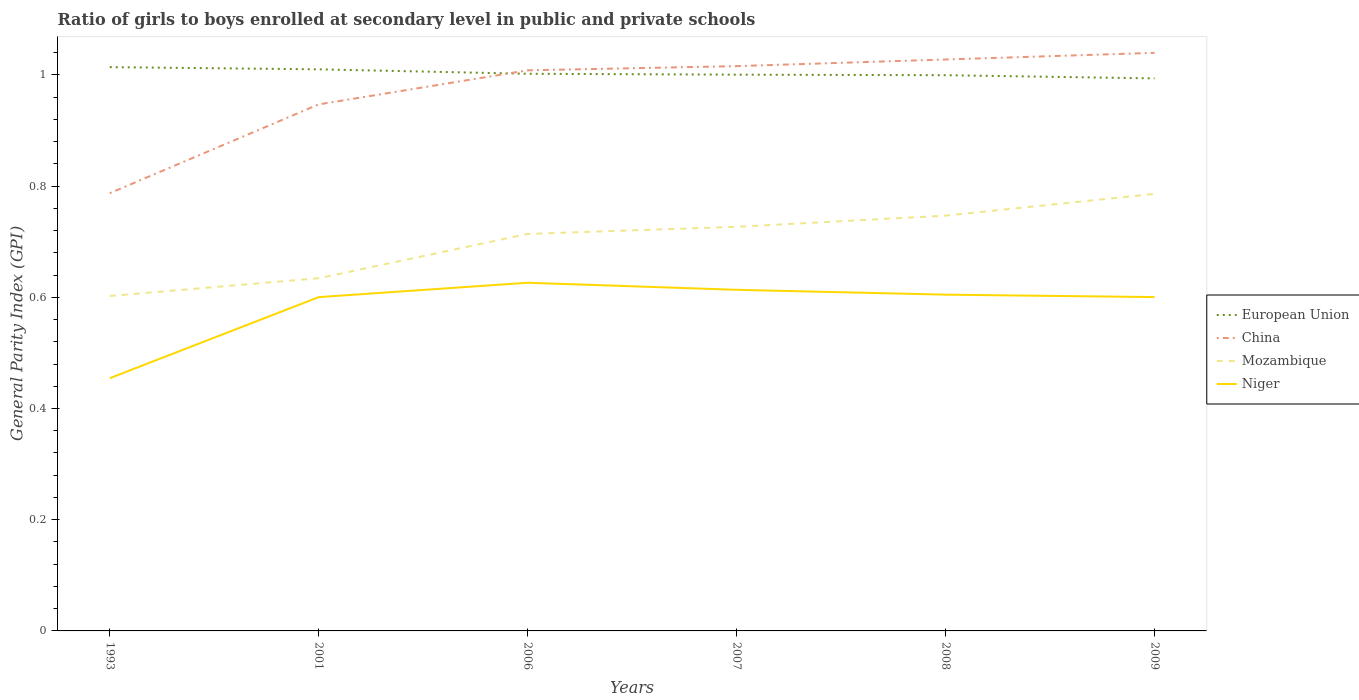Is the number of lines equal to the number of legend labels?
Your response must be concise. Yes. Across all years, what is the maximum general parity index in European Union?
Keep it short and to the point. 0.99. In which year was the general parity index in Mozambique maximum?
Ensure brevity in your answer.  1993. What is the total general parity index in China in the graph?
Provide a short and direct response. -0.16. What is the difference between the highest and the second highest general parity index in European Union?
Make the answer very short. 0.02. Is the general parity index in Niger strictly greater than the general parity index in Mozambique over the years?
Provide a succinct answer. Yes. How many lines are there?
Your answer should be compact. 4. How many years are there in the graph?
Your answer should be compact. 6. What is the difference between two consecutive major ticks on the Y-axis?
Offer a terse response. 0.2. Are the values on the major ticks of Y-axis written in scientific E-notation?
Ensure brevity in your answer.  No. Where does the legend appear in the graph?
Your response must be concise. Center right. How many legend labels are there?
Offer a terse response. 4. How are the legend labels stacked?
Your answer should be compact. Vertical. What is the title of the graph?
Your answer should be very brief. Ratio of girls to boys enrolled at secondary level in public and private schools. Does "Tajikistan" appear as one of the legend labels in the graph?
Offer a terse response. No. What is the label or title of the Y-axis?
Give a very brief answer. General Parity Index (GPI). What is the General Parity Index (GPI) in European Union in 1993?
Offer a terse response. 1.01. What is the General Parity Index (GPI) in China in 1993?
Offer a terse response. 0.79. What is the General Parity Index (GPI) in Mozambique in 1993?
Provide a short and direct response. 0.6. What is the General Parity Index (GPI) of Niger in 1993?
Your answer should be very brief. 0.45. What is the General Parity Index (GPI) of European Union in 2001?
Offer a very short reply. 1.01. What is the General Parity Index (GPI) in China in 2001?
Your response must be concise. 0.95. What is the General Parity Index (GPI) of Mozambique in 2001?
Your answer should be very brief. 0.63. What is the General Parity Index (GPI) of Niger in 2001?
Provide a succinct answer. 0.6. What is the General Parity Index (GPI) of European Union in 2006?
Offer a very short reply. 1. What is the General Parity Index (GPI) of China in 2006?
Your answer should be very brief. 1.01. What is the General Parity Index (GPI) in Mozambique in 2006?
Your response must be concise. 0.71. What is the General Parity Index (GPI) in Niger in 2006?
Provide a succinct answer. 0.63. What is the General Parity Index (GPI) of European Union in 2007?
Give a very brief answer. 1. What is the General Parity Index (GPI) of China in 2007?
Keep it short and to the point. 1.02. What is the General Parity Index (GPI) in Mozambique in 2007?
Your answer should be compact. 0.73. What is the General Parity Index (GPI) of Niger in 2007?
Ensure brevity in your answer.  0.61. What is the General Parity Index (GPI) of European Union in 2008?
Provide a succinct answer. 1. What is the General Parity Index (GPI) in China in 2008?
Give a very brief answer. 1.03. What is the General Parity Index (GPI) of Mozambique in 2008?
Your response must be concise. 0.75. What is the General Parity Index (GPI) in Niger in 2008?
Your answer should be very brief. 0.6. What is the General Parity Index (GPI) in European Union in 2009?
Make the answer very short. 0.99. What is the General Parity Index (GPI) in China in 2009?
Provide a succinct answer. 1.04. What is the General Parity Index (GPI) of Mozambique in 2009?
Offer a very short reply. 0.79. What is the General Parity Index (GPI) in Niger in 2009?
Provide a succinct answer. 0.6. Across all years, what is the maximum General Parity Index (GPI) of European Union?
Keep it short and to the point. 1.01. Across all years, what is the maximum General Parity Index (GPI) in China?
Your answer should be very brief. 1.04. Across all years, what is the maximum General Parity Index (GPI) in Mozambique?
Your answer should be compact. 0.79. Across all years, what is the maximum General Parity Index (GPI) of Niger?
Offer a terse response. 0.63. Across all years, what is the minimum General Parity Index (GPI) of European Union?
Offer a terse response. 0.99. Across all years, what is the minimum General Parity Index (GPI) of China?
Offer a very short reply. 0.79. Across all years, what is the minimum General Parity Index (GPI) of Mozambique?
Keep it short and to the point. 0.6. Across all years, what is the minimum General Parity Index (GPI) of Niger?
Your response must be concise. 0.45. What is the total General Parity Index (GPI) in European Union in the graph?
Offer a very short reply. 6.02. What is the total General Parity Index (GPI) in China in the graph?
Offer a very short reply. 5.83. What is the total General Parity Index (GPI) of Mozambique in the graph?
Ensure brevity in your answer.  4.21. What is the total General Parity Index (GPI) of Niger in the graph?
Make the answer very short. 3.5. What is the difference between the General Parity Index (GPI) in European Union in 1993 and that in 2001?
Provide a succinct answer. 0. What is the difference between the General Parity Index (GPI) of China in 1993 and that in 2001?
Your answer should be compact. -0.16. What is the difference between the General Parity Index (GPI) in Mozambique in 1993 and that in 2001?
Give a very brief answer. -0.03. What is the difference between the General Parity Index (GPI) in Niger in 1993 and that in 2001?
Your response must be concise. -0.15. What is the difference between the General Parity Index (GPI) in European Union in 1993 and that in 2006?
Your answer should be very brief. 0.01. What is the difference between the General Parity Index (GPI) in China in 1993 and that in 2006?
Offer a terse response. -0.22. What is the difference between the General Parity Index (GPI) of Mozambique in 1993 and that in 2006?
Offer a very short reply. -0.11. What is the difference between the General Parity Index (GPI) in Niger in 1993 and that in 2006?
Offer a terse response. -0.17. What is the difference between the General Parity Index (GPI) in European Union in 1993 and that in 2007?
Ensure brevity in your answer.  0.01. What is the difference between the General Parity Index (GPI) in China in 1993 and that in 2007?
Offer a very short reply. -0.23. What is the difference between the General Parity Index (GPI) in Mozambique in 1993 and that in 2007?
Your answer should be compact. -0.12. What is the difference between the General Parity Index (GPI) in Niger in 1993 and that in 2007?
Make the answer very short. -0.16. What is the difference between the General Parity Index (GPI) of European Union in 1993 and that in 2008?
Provide a succinct answer. 0.01. What is the difference between the General Parity Index (GPI) in China in 1993 and that in 2008?
Offer a very short reply. -0.24. What is the difference between the General Parity Index (GPI) of Mozambique in 1993 and that in 2008?
Your response must be concise. -0.14. What is the difference between the General Parity Index (GPI) in Niger in 1993 and that in 2008?
Give a very brief answer. -0.15. What is the difference between the General Parity Index (GPI) in European Union in 1993 and that in 2009?
Provide a short and direct response. 0.02. What is the difference between the General Parity Index (GPI) in China in 1993 and that in 2009?
Provide a short and direct response. -0.25. What is the difference between the General Parity Index (GPI) of Mozambique in 1993 and that in 2009?
Your answer should be compact. -0.18. What is the difference between the General Parity Index (GPI) of Niger in 1993 and that in 2009?
Keep it short and to the point. -0.15. What is the difference between the General Parity Index (GPI) of European Union in 2001 and that in 2006?
Your response must be concise. 0.01. What is the difference between the General Parity Index (GPI) of China in 2001 and that in 2006?
Keep it short and to the point. -0.06. What is the difference between the General Parity Index (GPI) of Mozambique in 2001 and that in 2006?
Offer a very short reply. -0.08. What is the difference between the General Parity Index (GPI) in Niger in 2001 and that in 2006?
Your answer should be compact. -0.03. What is the difference between the General Parity Index (GPI) in European Union in 2001 and that in 2007?
Offer a terse response. 0.01. What is the difference between the General Parity Index (GPI) in China in 2001 and that in 2007?
Ensure brevity in your answer.  -0.07. What is the difference between the General Parity Index (GPI) of Mozambique in 2001 and that in 2007?
Offer a very short reply. -0.09. What is the difference between the General Parity Index (GPI) in Niger in 2001 and that in 2007?
Give a very brief answer. -0.01. What is the difference between the General Parity Index (GPI) in European Union in 2001 and that in 2008?
Ensure brevity in your answer.  0.01. What is the difference between the General Parity Index (GPI) in China in 2001 and that in 2008?
Your answer should be very brief. -0.08. What is the difference between the General Parity Index (GPI) in Mozambique in 2001 and that in 2008?
Ensure brevity in your answer.  -0.11. What is the difference between the General Parity Index (GPI) in Niger in 2001 and that in 2008?
Provide a short and direct response. -0. What is the difference between the General Parity Index (GPI) of European Union in 2001 and that in 2009?
Offer a terse response. 0.02. What is the difference between the General Parity Index (GPI) of China in 2001 and that in 2009?
Provide a short and direct response. -0.09. What is the difference between the General Parity Index (GPI) in Mozambique in 2001 and that in 2009?
Make the answer very short. -0.15. What is the difference between the General Parity Index (GPI) in Niger in 2001 and that in 2009?
Ensure brevity in your answer.  -0. What is the difference between the General Parity Index (GPI) in European Union in 2006 and that in 2007?
Your answer should be very brief. 0. What is the difference between the General Parity Index (GPI) of China in 2006 and that in 2007?
Ensure brevity in your answer.  -0.01. What is the difference between the General Parity Index (GPI) of Mozambique in 2006 and that in 2007?
Your answer should be very brief. -0.01. What is the difference between the General Parity Index (GPI) in Niger in 2006 and that in 2007?
Offer a very short reply. 0.01. What is the difference between the General Parity Index (GPI) in European Union in 2006 and that in 2008?
Provide a short and direct response. 0. What is the difference between the General Parity Index (GPI) of China in 2006 and that in 2008?
Make the answer very short. -0.02. What is the difference between the General Parity Index (GPI) in Mozambique in 2006 and that in 2008?
Offer a very short reply. -0.03. What is the difference between the General Parity Index (GPI) of Niger in 2006 and that in 2008?
Your answer should be very brief. 0.02. What is the difference between the General Parity Index (GPI) of European Union in 2006 and that in 2009?
Provide a short and direct response. 0.01. What is the difference between the General Parity Index (GPI) in China in 2006 and that in 2009?
Provide a succinct answer. -0.03. What is the difference between the General Parity Index (GPI) of Mozambique in 2006 and that in 2009?
Your response must be concise. -0.07. What is the difference between the General Parity Index (GPI) in Niger in 2006 and that in 2009?
Offer a terse response. 0.03. What is the difference between the General Parity Index (GPI) of China in 2007 and that in 2008?
Make the answer very short. -0.01. What is the difference between the General Parity Index (GPI) of Mozambique in 2007 and that in 2008?
Provide a short and direct response. -0.02. What is the difference between the General Parity Index (GPI) in Niger in 2007 and that in 2008?
Provide a short and direct response. 0.01. What is the difference between the General Parity Index (GPI) in European Union in 2007 and that in 2009?
Provide a succinct answer. 0.01. What is the difference between the General Parity Index (GPI) in China in 2007 and that in 2009?
Offer a very short reply. -0.02. What is the difference between the General Parity Index (GPI) in Mozambique in 2007 and that in 2009?
Offer a very short reply. -0.06. What is the difference between the General Parity Index (GPI) in Niger in 2007 and that in 2009?
Give a very brief answer. 0.01. What is the difference between the General Parity Index (GPI) of European Union in 2008 and that in 2009?
Provide a short and direct response. 0.01. What is the difference between the General Parity Index (GPI) in China in 2008 and that in 2009?
Make the answer very short. -0.01. What is the difference between the General Parity Index (GPI) of Mozambique in 2008 and that in 2009?
Offer a very short reply. -0.04. What is the difference between the General Parity Index (GPI) of Niger in 2008 and that in 2009?
Make the answer very short. 0. What is the difference between the General Parity Index (GPI) in European Union in 1993 and the General Parity Index (GPI) in China in 2001?
Your answer should be very brief. 0.07. What is the difference between the General Parity Index (GPI) in European Union in 1993 and the General Parity Index (GPI) in Mozambique in 2001?
Offer a very short reply. 0.38. What is the difference between the General Parity Index (GPI) of European Union in 1993 and the General Parity Index (GPI) of Niger in 2001?
Give a very brief answer. 0.41. What is the difference between the General Parity Index (GPI) of China in 1993 and the General Parity Index (GPI) of Mozambique in 2001?
Offer a terse response. 0.15. What is the difference between the General Parity Index (GPI) of China in 1993 and the General Parity Index (GPI) of Niger in 2001?
Provide a short and direct response. 0.19. What is the difference between the General Parity Index (GPI) in Mozambique in 1993 and the General Parity Index (GPI) in Niger in 2001?
Provide a short and direct response. 0. What is the difference between the General Parity Index (GPI) in European Union in 1993 and the General Parity Index (GPI) in China in 2006?
Offer a terse response. 0.01. What is the difference between the General Parity Index (GPI) in European Union in 1993 and the General Parity Index (GPI) in Mozambique in 2006?
Keep it short and to the point. 0.3. What is the difference between the General Parity Index (GPI) in European Union in 1993 and the General Parity Index (GPI) in Niger in 2006?
Your answer should be compact. 0.39. What is the difference between the General Parity Index (GPI) of China in 1993 and the General Parity Index (GPI) of Mozambique in 2006?
Keep it short and to the point. 0.07. What is the difference between the General Parity Index (GPI) in China in 1993 and the General Parity Index (GPI) in Niger in 2006?
Offer a terse response. 0.16. What is the difference between the General Parity Index (GPI) of Mozambique in 1993 and the General Parity Index (GPI) of Niger in 2006?
Offer a very short reply. -0.02. What is the difference between the General Parity Index (GPI) of European Union in 1993 and the General Parity Index (GPI) of China in 2007?
Offer a very short reply. -0. What is the difference between the General Parity Index (GPI) in European Union in 1993 and the General Parity Index (GPI) in Mozambique in 2007?
Provide a short and direct response. 0.29. What is the difference between the General Parity Index (GPI) in European Union in 1993 and the General Parity Index (GPI) in Niger in 2007?
Make the answer very short. 0.4. What is the difference between the General Parity Index (GPI) in China in 1993 and the General Parity Index (GPI) in Mozambique in 2007?
Provide a short and direct response. 0.06. What is the difference between the General Parity Index (GPI) in China in 1993 and the General Parity Index (GPI) in Niger in 2007?
Provide a succinct answer. 0.17. What is the difference between the General Parity Index (GPI) in Mozambique in 1993 and the General Parity Index (GPI) in Niger in 2007?
Ensure brevity in your answer.  -0.01. What is the difference between the General Parity Index (GPI) of European Union in 1993 and the General Parity Index (GPI) of China in 2008?
Your answer should be compact. -0.01. What is the difference between the General Parity Index (GPI) in European Union in 1993 and the General Parity Index (GPI) in Mozambique in 2008?
Your response must be concise. 0.27. What is the difference between the General Parity Index (GPI) of European Union in 1993 and the General Parity Index (GPI) of Niger in 2008?
Offer a terse response. 0.41. What is the difference between the General Parity Index (GPI) of China in 1993 and the General Parity Index (GPI) of Mozambique in 2008?
Provide a succinct answer. 0.04. What is the difference between the General Parity Index (GPI) in China in 1993 and the General Parity Index (GPI) in Niger in 2008?
Make the answer very short. 0.18. What is the difference between the General Parity Index (GPI) of Mozambique in 1993 and the General Parity Index (GPI) of Niger in 2008?
Your answer should be very brief. -0. What is the difference between the General Parity Index (GPI) of European Union in 1993 and the General Parity Index (GPI) of China in 2009?
Your response must be concise. -0.03. What is the difference between the General Parity Index (GPI) of European Union in 1993 and the General Parity Index (GPI) of Mozambique in 2009?
Provide a succinct answer. 0.23. What is the difference between the General Parity Index (GPI) in European Union in 1993 and the General Parity Index (GPI) in Niger in 2009?
Provide a short and direct response. 0.41. What is the difference between the General Parity Index (GPI) of China in 1993 and the General Parity Index (GPI) of Mozambique in 2009?
Ensure brevity in your answer.  0. What is the difference between the General Parity Index (GPI) of China in 1993 and the General Parity Index (GPI) of Niger in 2009?
Ensure brevity in your answer.  0.19. What is the difference between the General Parity Index (GPI) of Mozambique in 1993 and the General Parity Index (GPI) of Niger in 2009?
Keep it short and to the point. 0. What is the difference between the General Parity Index (GPI) of European Union in 2001 and the General Parity Index (GPI) of China in 2006?
Provide a short and direct response. 0. What is the difference between the General Parity Index (GPI) of European Union in 2001 and the General Parity Index (GPI) of Mozambique in 2006?
Give a very brief answer. 0.3. What is the difference between the General Parity Index (GPI) in European Union in 2001 and the General Parity Index (GPI) in Niger in 2006?
Keep it short and to the point. 0.38. What is the difference between the General Parity Index (GPI) in China in 2001 and the General Parity Index (GPI) in Mozambique in 2006?
Make the answer very short. 0.23. What is the difference between the General Parity Index (GPI) in China in 2001 and the General Parity Index (GPI) in Niger in 2006?
Keep it short and to the point. 0.32. What is the difference between the General Parity Index (GPI) of Mozambique in 2001 and the General Parity Index (GPI) of Niger in 2006?
Make the answer very short. 0.01. What is the difference between the General Parity Index (GPI) in European Union in 2001 and the General Parity Index (GPI) in China in 2007?
Offer a terse response. -0.01. What is the difference between the General Parity Index (GPI) of European Union in 2001 and the General Parity Index (GPI) of Mozambique in 2007?
Provide a succinct answer. 0.28. What is the difference between the General Parity Index (GPI) of European Union in 2001 and the General Parity Index (GPI) of Niger in 2007?
Offer a terse response. 0.4. What is the difference between the General Parity Index (GPI) in China in 2001 and the General Parity Index (GPI) in Mozambique in 2007?
Make the answer very short. 0.22. What is the difference between the General Parity Index (GPI) of China in 2001 and the General Parity Index (GPI) of Niger in 2007?
Your response must be concise. 0.33. What is the difference between the General Parity Index (GPI) in Mozambique in 2001 and the General Parity Index (GPI) in Niger in 2007?
Give a very brief answer. 0.02. What is the difference between the General Parity Index (GPI) of European Union in 2001 and the General Parity Index (GPI) of China in 2008?
Ensure brevity in your answer.  -0.02. What is the difference between the General Parity Index (GPI) of European Union in 2001 and the General Parity Index (GPI) of Mozambique in 2008?
Keep it short and to the point. 0.26. What is the difference between the General Parity Index (GPI) in European Union in 2001 and the General Parity Index (GPI) in Niger in 2008?
Ensure brevity in your answer.  0.41. What is the difference between the General Parity Index (GPI) of China in 2001 and the General Parity Index (GPI) of Mozambique in 2008?
Offer a terse response. 0.2. What is the difference between the General Parity Index (GPI) of China in 2001 and the General Parity Index (GPI) of Niger in 2008?
Your response must be concise. 0.34. What is the difference between the General Parity Index (GPI) in Mozambique in 2001 and the General Parity Index (GPI) in Niger in 2008?
Give a very brief answer. 0.03. What is the difference between the General Parity Index (GPI) in European Union in 2001 and the General Parity Index (GPI) in China in 2009?
Offer a terse response. -0.03. What is the difference between the General Parity Index (GPI) in European Union in 2001 and the General Parity Index (GPI) in Mozambique in 2009?
Offer a very short reply. 0.22. What is the difference between the General Parity Index (GPI) in European Union in 2001 and the General Parity Index (GPI) in Niger in 2009?
Give a very brief answer. 0.41. What is the difference between the General Parity Index (GPI) in China in 2001 and the General Parity Index (GPI) in Mozambique in 2009?
Provide a short and direct response. 0.16. What is the difference between the General Parity Index (GPI) of China in 2001 and the General Parity Index (GPI) of Niger in 2009?
Give a very brief answer. 0.35. What is the difference between the General Parity Index (GPI) of Mozambique in 2001 and the General Parity Index (GPI) of Niger in 2009?
Make the answer very short. 0.03. What is the difference between the General Parity Index (GPI) of European Union in 2006 and the General Parity Index (GPI) of China in 2007?
Offer a terse response. -0.01. What is the difference between the General Parity Index (GPI) of European Union in 2006 and the General Parity Index (GPI) of Mozambique in 2007?
Offer a very short reply. 0.28. What is the difference between the General Parity Index (GPI) of European Union in 2006 and the General Parity Index (GPI) of Niger in 2007?
Your answer should be compact. 0.39. What is the difference between the General Parity Index (GPI) of China in 2006 and the General Parity Index (GPI) of Mozambique in 2007?
Keep it short and to the point. 0.28. What is the difference between the General Parity Index (GPI) in China in 2006 and the General Parity Index (GPI) in Niger in 2007?
Your answer should be very brief. 0.39. What is the difference between the General Parity Index (GPI) in Mozambique in 2006 and the General Parity Index (GPI) in Niger in 2007?
Provide a succinct answer. 0.1. What is the difference between the General Parity Index (GPI) in European Union in 2006 and the General Parity Index (GPI) in China in 2008?
Offer a terse response. -0.03. What is the difference between the General Parity Index (GPI) in European Union in 2006 and the General Parity Index (GPI) in Mozambique in 2008?
Give a very brief answer. 0.26. What is the difference between the General Parity Index (GPI) of European Union in 2006 and the General Parity Index (GPI) of Niger in 2008?
Offer a terse response. 0.4. What is the difference between the General Parity Index (GPI) in China in 2006 and the General Parity Index (GPI) in Mozambique in 2008?
Provide a short and direct response. 0.26. What is the difference between the General Parity Index (GPI) of China in 2006 and the General Parity Index (GPI) of Niger in 2008?
Your response must be concise. 0.4. What is the difference between the General Parity Index (GPI) in Mozambique in 2006 and the General Parity Index (GPI) in Niger in 2008?
Provide a succinct answer. 0.11. What is the difference between the General Parity Index (GPI) of European Union in 2006 and the General Parity Index (GPI) of China in 2009?
Offer a very short reply. -0.04. What is the difference between the General Parity Index (GPI) in European Union in 2006 and the General Parity Index (GPI) in Mozambique in 2009?
Offer a terse response. 0.22. What is the difference between the General Parity Index (GPI) in European Union in 2006 and the General Parity Index (GPI) in Niger in 2009?
Provide a succinct answer. 0.4. What is the difference between the General Parity Index (GPI) in China in 2006 and the General Parity Index (GPI) in Mozambique in 2009?
Offer a very short reply. 0.22. What is the difference between the General Parity Index (GPI) of China in 2006 and the General Parity Index (GPI) of Niger in 2009?
Provide a succinct answer. 0.41. What is the difference between the General Parity Index (GPI) of Mozambique in 2006 and the General Parity Index (GPI) of Niger in 2009?
Ensure brevity in your answer.  0.11. What is the difference between the General Parity Index (GPI) in European Union in 2007 and the General Parity Index (GPI) in China in 2008?
Provide a succinct answer. -0.03. What is the difference between the General Parity Index (GPI) of European Union in 2007 and the General Parity Index (GPI) of Mozambique in 2008?
Make the answer very short. 0.25. What is the difference between the General Parity Index (GPI) in European Union in 2007 and the General Parity Index (GPI) in Niger in 2008?
Ensure brevity in your answer.  0.4. What is the difference between the General Parity Index (GPI) in China in 2007 and the General Parity Index (GPI) in Mozambique in 2008?
Give a very brief answer. 0.27. What is the difference between the General Parity Index (GPI) of China in 2007 and the General Parity Index (GPI) of Niger in 2008?
Offer a very short reply. 0.41. What is the difference between the General Parity Index (GPI) in Mozambique in 2007 and the General Parity Index (GPI) in Niger in 2008?
Offer a very short reply. 0.12. What is the difference between the General Parity Index (GPI) in European Union in 2007 and the General Parity Index (GPI) in China in 2009?
Your answer should be very brief. -0.04. What is the difference between the General Parity Index (GPI) in European Union in 2007 and the General Parity Index (GPI) in Mozambique in 2009?
Keep it short and to the point. 0.21. What is the difference between the General Parity Index (GPI) in China in 2007 and the General Parity Index (GPI) in Mozambique in 2009?
Keep it short and to the point. 0.23. What is the difference between the General Parity Index (GPI) of China in 2007 and the General Parity Index (GPI) of Niger in 2009?
Your response must be concise. 0.42. What is the difference between the General Parity Index (GPI) of Mozambique in 2007 and the General Parity Index (GPI) of Niger in 2009?
Ensure brevity in your answer.  0.13. What is the difference between the General Parity Index (GPI) in European Union in 2008 and the General Parity Index (GPI) in China in 2009?
Provide a succinct answer. -0.04. What is the difference between the General Parity Index (GPI) in European Union in 2008 and the General Parity Index (GPI) in Mozambique in 2009?
Provide a short and direct response. 0.21. What is the difference between the General Parity Index (GPI) in European Union in 2008 and the General Parity Index (GPI) in Niger in 2009?
Offer a terse response. 0.4. What is the difference between the General Parity Index (GPI) of China in 2008 and the General Parity Index (GPI) of Mozambique in 2009?
Make the answer very short. 0.24. What is the difference between the General Parity Index (GPI) in China in 2008 and the General Parity Index (GPI) in Niger in 2009?
Provide a succinct answer. 0.43. What is the difference between the General Parity Index (GPI) of Mozambique in 2008 and the General Parity Index (GPI) of Niger in 2009?
Your response must be concise. 0.15. What is the average General Parity Index (GPI) in China per year?
Your answer should be compact. 0.97. What is the average General Parity Index (GPI) in Mozambique per year?
Your answer should be compact. 0.7. What is the average General Parity Index (GPI) of Niger per year?
Provide a short and direct response. 0.58. In the year 1993, what is the difference between the General Parity Index (GPI) of European Union and General Parity Index (GPI) of China?
Keep it short and to the point. 0.23. In the year 1993, what is the difference between the General Parity Index (GPI) of European Union and General Parity Index (GPI) of Mozambique?
Keep it short and to the point. 0.41. In the year 1993, what is the difference between the General Parity Index (GPI) in European Union and General Parity Index (GPI) in Niger?
Give a very brief answer. 0.56. In the year 1993, what is the difference between the General Parity Index (GPI) of China and General Parity Index (GPI) of Mozambique?
Make the answer very short. 0.18. In the year 1993, what is the difference between the General Parity Index (GPI) of China and General Parity Index (GPI) of Niger?
Make the answer very short. 0.33. In the year 1993, what is the difference between the General Parity Index (GPI) of Mozambique and General Parity Index (GPI) of Niger?
Offer a terse response. 0.15. In the year 2001, what is the difference between the General Parity Index (GPI) of European Union and General Parity Index (GPI) of China?
Make the answer very short. 0.06. In the year 2001, what is the difference between the General Parity Index (GPI) of European Union and General Parity Index (GPI) of Mozambique?
Your response must be concise. 0.38. In the year 2001, what is the difference between the General Parity Index (GPI) of European Union and General Parity Index (GPI) of Niger?
Offer a terse response. 0.41. In the year 2001, what is the difference between the General Parity Index (GPI) of China and General Parity Index (GPI) of Mozambique?
Give a very brief answer. 0.31. In the year 2001, what is the difference between the General Parity Index (GPI) of China and General Parity Index (GPI) of Niger?
Your response must be concise. 0.35. In the year 2001, what is the difference between the General Parity Index (GPI) of Mozambique and General Parity Index (GPI) of Niger?
Ensure brevity in your answer.  0.03. In the year 2006, what is the difference between the General Parity Index (GPI) in European Union and General Parity Index (GPI) in China?
Keep it short and to the point. -0.01. In the year 2006, what is the difference between the General Parity Index (GPI) in European Union and General Parity Index (GPI) in Mozambique?
Offer a very short reply. 0.29. In the year 2006, what is the difference between the General Parity Index (GPI) of European Union and General Parity Index (GPI) of Niger?
Your answer should be compact. 0.38. In the year 2006, what is the difference between the General Parity Index (GPI) in China and General Parity Index (GPI) in Mozambique?
Ensure brevity in your answer.  0.29. In the year 2006, what is the difference between the General Parity Index (GPI) in China and General Parity Index (GPI) in Niger?
Your answer should be very brief. 0.38. In the year 2006, what is the difference between the General Parity Index (GPI) in Mozambique and General Parity Index (GPI) in Niger?
Offer a terse response. 0.09. In the year 2007, what is the difference between the General Parity Index (GPI) in European Union and General Parity Index (GPI) in China?
Provide a succinct answer. -0.02. In the year 2007, what is the difference between the General Parity Index (GPI) in European Union and General Parity Index (GPI) in Mozambique?
Offer a very short reply. 0.27. In the year 2007, what is the difference between the General Parity Index (GPI) in European Union and General Parity Index (GPI) in Niger?
Give a very brief answer. 0.39. In the year 2007, what is the difference between the General Parity Index (GPI) of China and General Parity Index (GPI) of Mozambique?
Give a very brief answer. 0.29. In the year 2007, what is the difference between the General Parity Index (GPI) of China and General Parity Index (GPI) of Niger?
Give a very brief answer. 0.4. In the year 2007, what is the difference between the General Parity Index (GPI) of Mozambique and General Parity Index (GPI) of Niger?
Keep it short and to the point. 0.11. In the year 2008, what is the difference between the General Parity Index (GPI) in European Union and General Parity Index (GPI) in China?
Give a very brief answer. -0.03. In the year 2008, what is the difference between the General Parity Index (GPI) of European Union and General Parity Index (GPI) of Mozambique?
Your answer should be very brief. 0.25. In the year 2008, what is the difference between the General Parity Index (GPI) in European Union and General Parity Index (GPI) in Niger?
Your answer should be very brief. 0.39. In the year 2008, what is the difference between the General Parity Index (GPI) in China and General Parity Index (GPI) in Mozambique?
Give a very brief answer. 0.28. In the year 2008, what is the difference between the General Parity Index (GPI) in China and General Parity Index (GPI) in Niger?
Provide a short and direct response. 0.42. In the year 2008, what is the difference between the General Parity Index (GPI) in Mozambique and General Parity Index (GPI) in Niger?
Provide a short and direct response. 0.14. In the year 2009, what is the difference between the General Parity Index (GPI) of European Union and General Parity Index (GPI) of China?
Offer a very short reply. -0.05. In the year 2009, what is the difference between the General Parity Index (GPI) in European Union and General Parity Index (GPI) in Mozambique?
Your answer should be very brief. 0.21. In the year 2009, what is the difference between the General Parity Index (GPI) of European Union and General Parity Index (GPI) of Niger?
Your response must be concise. 0.39. In the year 2009, what is the difference between the General Parity Index (GPI) in China and General Parity Index (GPI) in Mozambique?
Provide a succinct answer. 0.25. In the year 2009, what is the difference between the General Parity Index (GPI) in China and General Parity Index (GPI) in Niger?
Give a very brief answer. 0.44. In the year 2009, what is the difference between the General Parity Index (GPI) of Mozambique and General Parity Index (GPI) of Niger?
Keep it short and to the point. 0.19. What is the ratio of the General Parity Index (GPI) in China in 1993 to that in 2001?
Offer a terse response. 0.83. What is the ratio of the General Parity Index (GPI) in Mozambique in 1993 to that in 2001?
Provide a short and direct response. 0.95. What is the ratio of the General Parity Index (GPI) in Niger in 1993 to that in 2001?
Your answer should be compact. 0.76. What is the ratio of the General Parity Index (GPI) in European Union in 1993 to that in 2006?
Offer a terse response. 1.01. What is the ratio of the General Parity Index (GPI) of China in 1993 to that in 2006?
Keep it short and to the point. 0.78. What is the ratio of the General Parity Index (GPI) in Mozambique in 1993 to that in 2006?
Offer a terse response. 0.84. What is the ratio of the General Parity Index (GPI) of Niger in 1993 to that in 2006?
Ensure brevity in your answer.  0.73. What is the ratio of the General Parity Index (GPI) of European Union in 1993 to that in 2007?
Offer a terse response. 1.01. What is the ratio of the General Parity Index (GPI) in China in 1993 to that in 2007?
Give a very brief answer. 0.78. What is the ratio of the General Parity Index (GPI) in Mozambique in 1993 to that in 2007?
Give a very brief answer. 0.83. What is the ratio of the General Parity Index (GPI) in Niger in 1993 to that in 2007?
Offer a terse response. 0.74. What is the ratio of the General Parity Index (GPI) in European Union in 1993 to that in 2008?
Keep it short and to the point. 1.01. What is the ratio of the General Parity Index (GPI) in China in 1993 to that in 2008?
Offer a very short reply. 0.77. What is the ratio of the General Parity Index (GPI) of Mozambique in 1993 to that in 2008?
Make the answer very short. 0.81. What is the ratio of the General Parity Index (GPI) in Niger in 1993 to that in 2008?
Offer a terse response. 0.75. What is the ratio of the General Parity Index (GPI) of European Union in 1993 to that in 2009?
Your answer should be compact. 1.02. What is the ratio of the General Parity Index (GPI) of China in 1993 to that in 2009?
Give a very brief answer. 0.76. What is the ratio of the General Parity Index (GPI) in Mozambique in 1993 to that in 2009?
Offer a terse response. 0.77. What is the ratio of the General Parity Index (GPI) of Niger in 1993 to that in 2009?
Provide a short and direct response. 0.76. What is the ratio of the General Parity Index (GPI) in European Union in 2001 to that in 2006?
Your answer should be compact. 1.01. What is the ratio of the General Parity Index (GPI) in China in 2001 to that in 2006?
Your answer should be very brief. 0.94. What is the ratio of the General Parity Index (GPI) of Mozambique in 2001 to that in 2006?
Ensure brevity in your answer.  0.89. What is the ratio of the General Parity Index (GPI) in Niger in 2001 to that in 2006?
Keep it short and to the point. 0.96. What is the ratio of the General Parity Index (GPI) in European Union in 2001 to that in 2007?
Make the answer very short. 1.01. What is the ratio of the General Parity Index (GPI) in China in 2001 to that in 2007?
Provide a short and direct response. 0.93. What is the ratio of the General Parity Index (GPI) in Mozambique in 2001 to that in 2007?
Offer a very short reply. 0.87. What is the ratio of the General Parity Index (GPI) in Niger in 2001 to that in 2007?
Provide a succinct answer. 0.98. What is the ratio of the General Parity Index (GPI) in European Union in 2001 to that in 2008?
Make the answer very short. 1.01. What is the ratio of the General Parity Index (GPI) of China in 2001 to that in 2008?
Offer a terse response. 0.92. What is the ratio of the General Parity Index (GPI) of Mozambique in 2001 to that in 2008?
Your response must be concise. 0.85. What is the ratio of the General Parity Index (GPI) of European Union in 2001 to that in 2009?
Ensure brevity in your answer.  1.02. What is the ratio of the General Parity Index (GPI) of China in 2001 to that in 2009?
Make the answer very short. 0.91. What is the ratio of the General Parity Index (GPI) of Mozambique in 2001 to that in 2009?
Keep it short and to the point. 0.81. What is the ratio of the General Parity Index (GPI) of European Union in 2006 to that in 2007?
Make the answer very short. 1. What is the ratio of the General Parity Index (GPI) of Mozambique in 2006 to that in 2007?
Provide a succinct answer. 0.98. What is the ratio of the General Parity Index (GPI) of Niger in 2006 to that in 2007?
Your answer should be very brief. 1.02. What is the ratio of the General Parity Index (GPI) of Mozambique in 2006 to that in 2008?
Your response must be concise. 0.96. What is the ratio of the General Parity Index (GPI) in Niger in 2006 to that in 2008?
Offer a terse response. 1.04. What is the ratio of the General Parity Index (GPI) of European Union in 2006 to that in 2009?
Your answer should be compact. 1.01. What is the ratio of the General Parity Index (GPI) of China in 2006 to that in 2009?
Offer a very short reply. 0.97. What is the ratio of the General Parity Index (GPI) in Mozambique in 2006 to that in 2009?
Keep it short and to the point. 0.91. What is the ratio of the General Parity Index (GPI) of Niger in 2006 to that in 2009?
Your answer should be very brief. 1.04. What is the ratio of the General Parity Index (GPI) in China in 2007 to that in 2008?
Keep it short and to the point. 0.99. What is the ratio of the General Parity Index (GPI) in Mozambique in 2007 to that in 2008?
Provide a short and direct response. 0.97. What is the ratio of the General Parity Index (GPI) in Niger in 2007 to that in 2008?
Offer a terse response. 1.01. What is the ratio of the General Parity Index (GPI) of Mozambique in 2007 to that in 2009?
Offer a very short reply. 0.92. What is the ratio of the General Parity Index (GPI) of Niger in 2007 to that in 2009?
Your answer should be compact. 1.02. What is the ratio of the General Parity Index (GPI) in Mozambique in 2008 to that in 2009?
Your answer should be very brief. 0.95. What is the ratio of the General Parity Index (GPI) of Niger in 2008 to that in 2009?
Ensure brevity in your answer.  1.01. What is the difference between the highest and the second highest General Parity Index (GPI) of European Union?
Your answer should be compact. 0. What is the difference between the highest and the second highest General Parity Index (GPI) of China?
Your response must be concise. 0.01. What is the difference between the highest and the second highest General Parity Index (GPI) of Mozambique?
Your answer should be compact. 0.04. What is the difference between the highest and the second highest General Parity Index (GPI) in Niger?
Keep it short and to the point. 0.01. What is the difference between the highest and the lowest General Parity Index (GPI) of European Union?
Provide a short and direct response. 0.02. What is the difference between the highest and the lowest General Parity Index (GPI) of China?
Keep it short and to the point. 0.25. What is the difference between the highest and the lowest General Parity Index (GPI) of Mozambique?
Your answer should be compact. 0.18. What is the difference between the highest and the lowest General Parity Index (GPI) of Niger?
Offer a terse response. 0.17. 